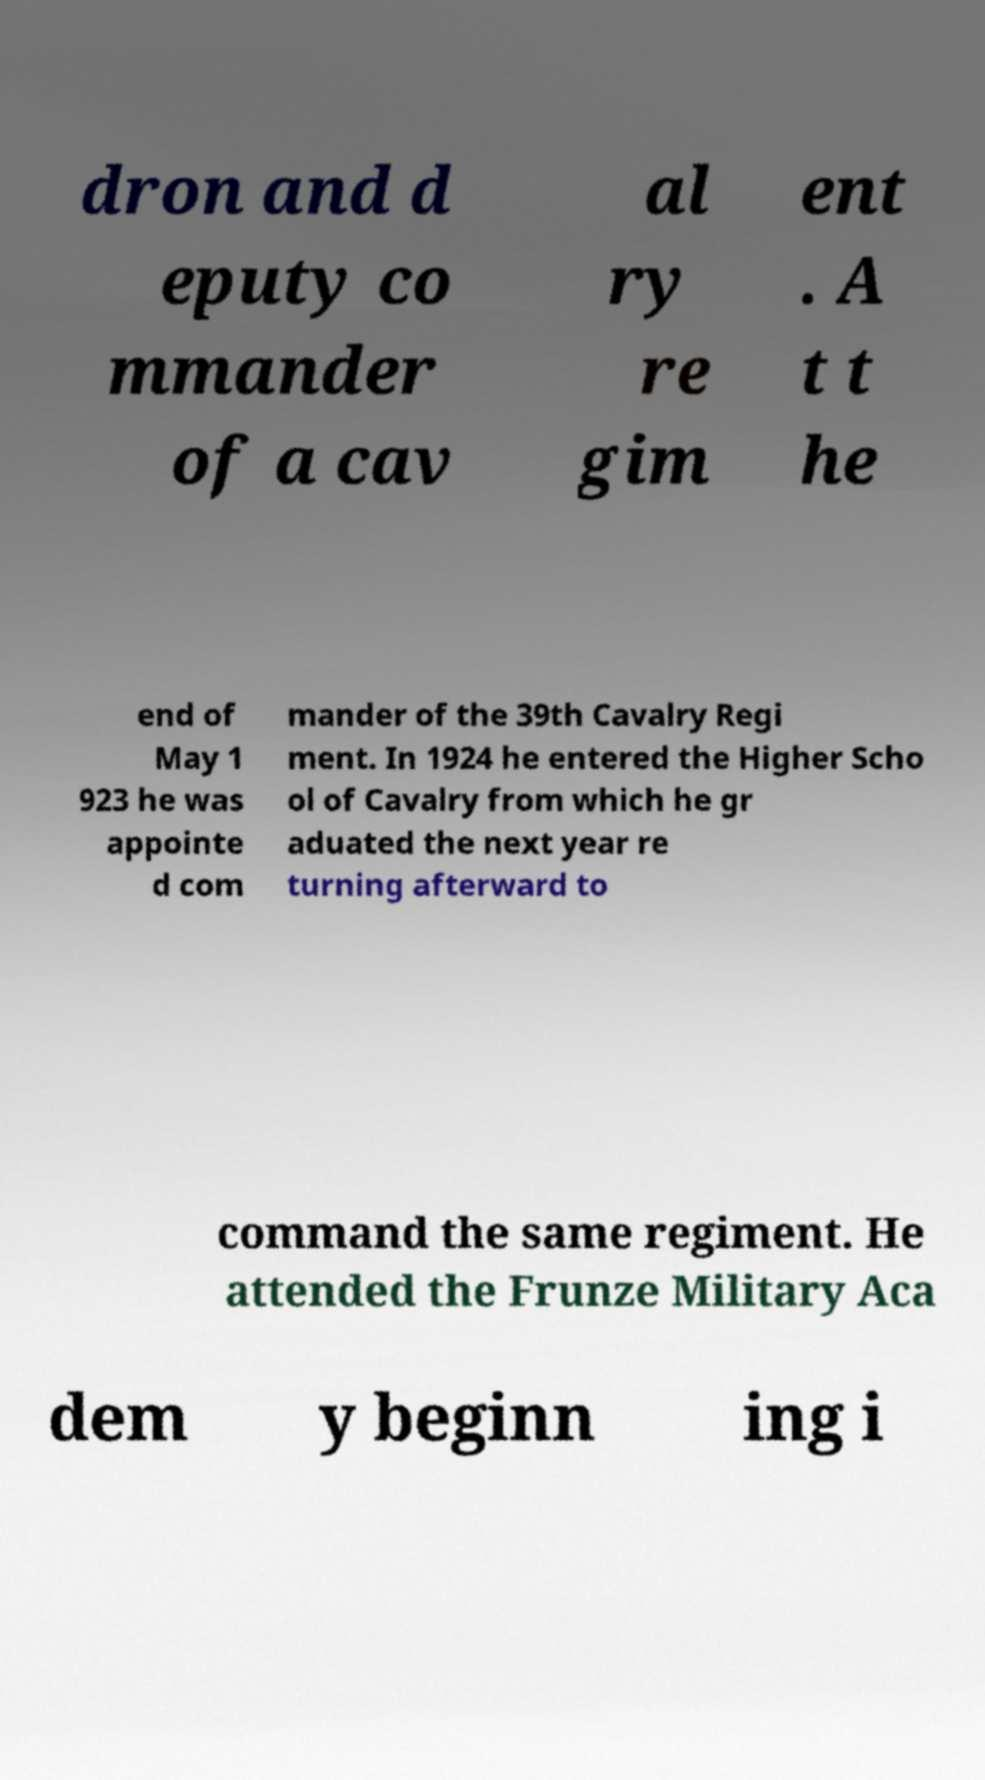Can you accurately transcribe the text from the provided image for me? dron and d eputy co mmander of a cav al ry re gim ent . A t t he end of May 1 923 he was appointe d com mander of the 39th Cavalry Regi ment. In 1924 he entered the Higher Scho ol of Cavalry from which he gr aduated the next year re turning afterward to command the same regiment. He attended the Frunze Military Aca dem y beginn ing i 